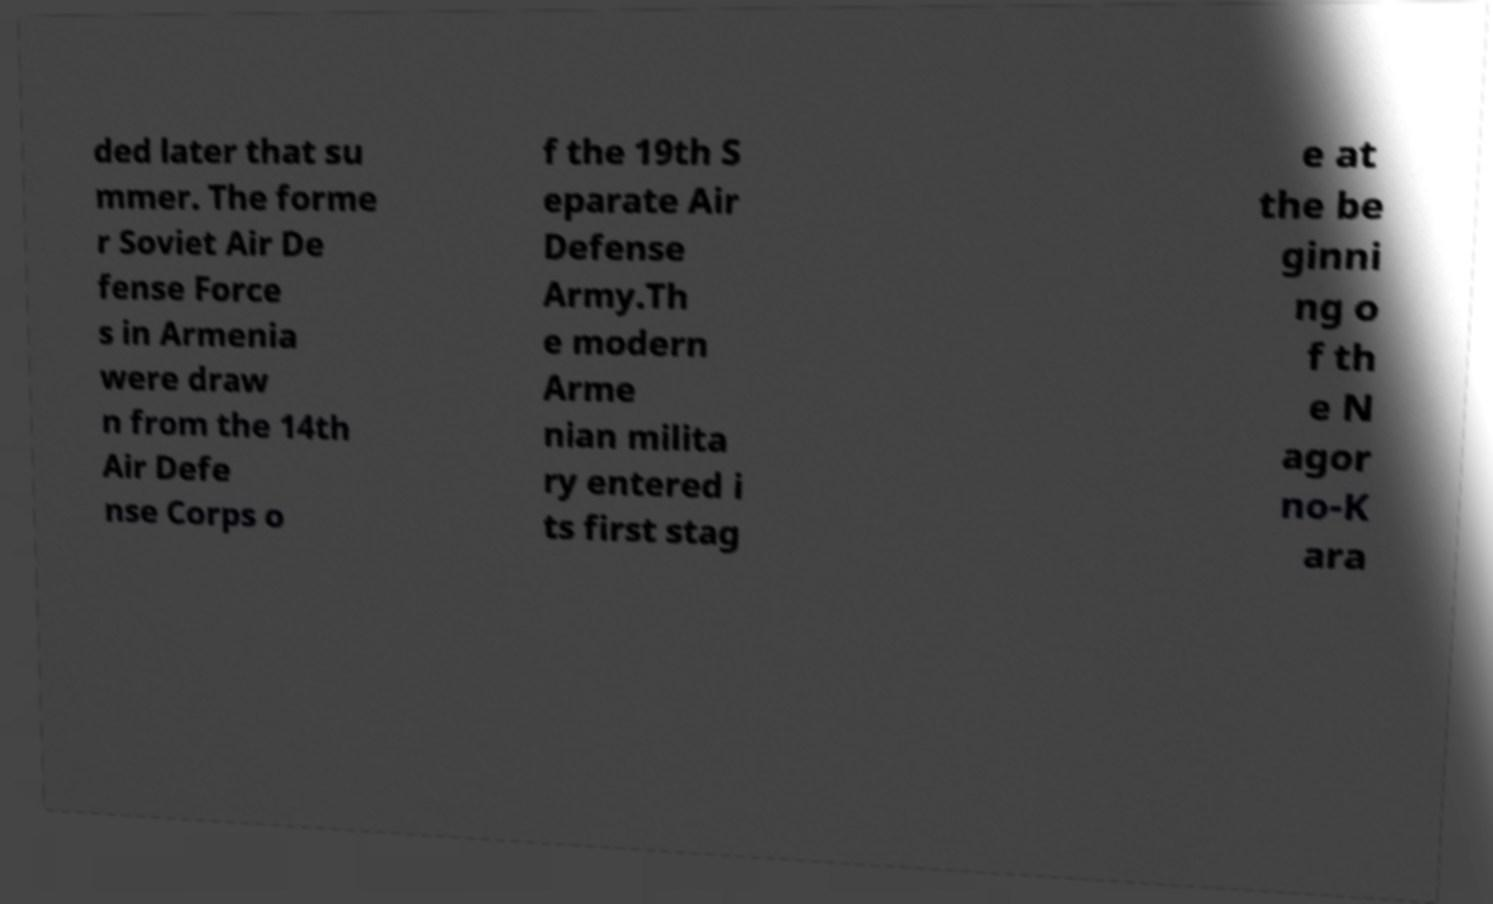Could you assist in decoding the text presented in this image and type it out clearly? ded later that su mmer. The forme r Soviet Air De fense Force s in Armenia were draw n from the 14th Air Defe nse Corps o f the 19th S eparate Air Defense Army.Th e modern Arme nian milita ry entered i ts first stag e at the be ginni ng o f th e N agor no-K ara 